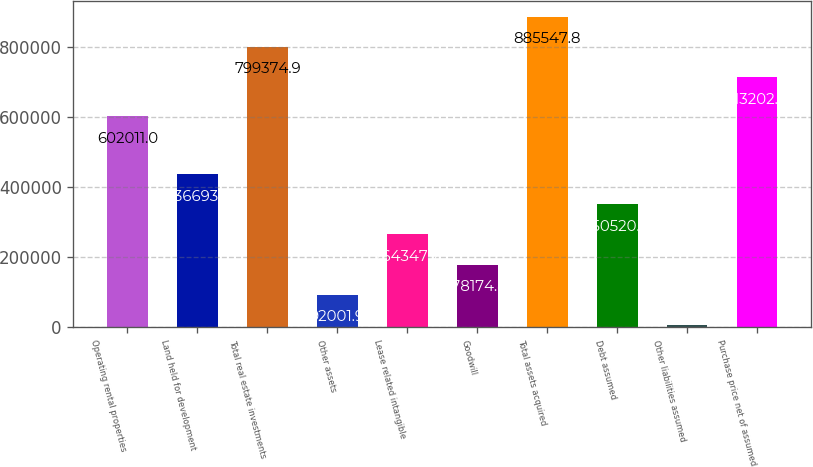Convert chart. <chart><loc_0><loc_0><loc_500><loc_500><bar_chart><fcel>Operating rental properties<fcel>Land held for development<fcel>Total real estate investments<fcel>Other assets<fcel>Lease related intangible<fcel>Goodwill<fcel>Total assets acquired<fcel>Debt assumed<fcel>Other liabilities assumed<fcel>Purchase price net of assumed<nl><fcel>602011<fcel>436694<fcel>799375<fcel>92001.9<fcel>264348<fcel>178175<fcel>885548<fcel>350521<fcel>5829<fcel>713202<nl></chart> 